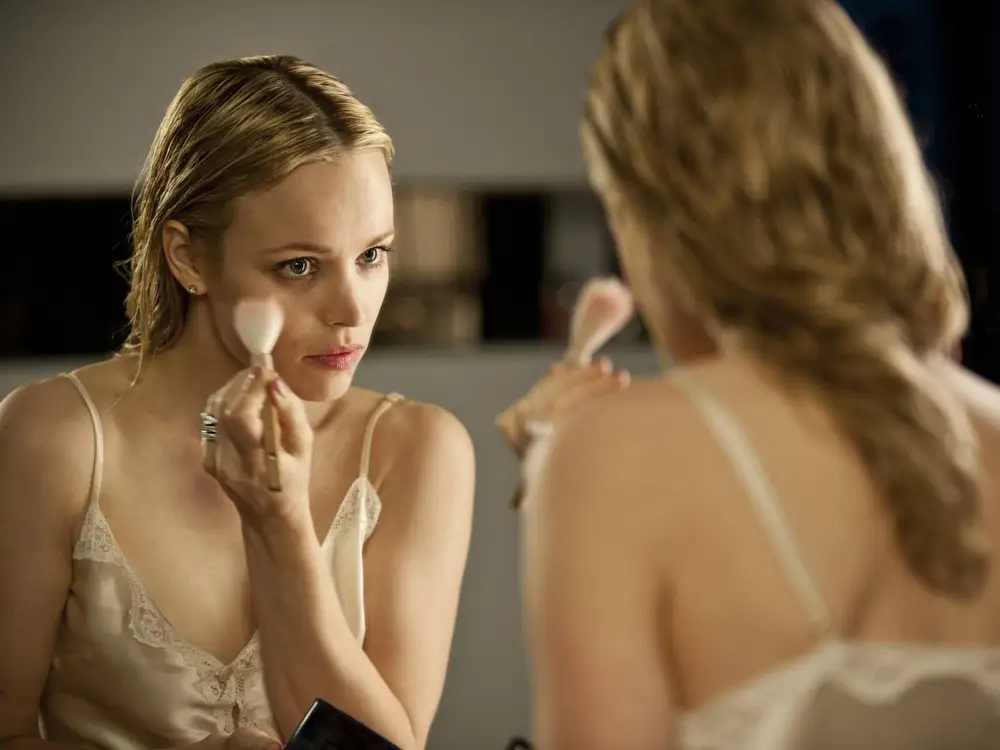What mood does this image evoke, and how is it achieved? The image evokes a mood of tranquility and introspection, achieved through the use of soft lighting, which creates gentle shadows and highlights the calm expression of the woman. Her focused demeanor and the quiet setting, indicated by her attire and the solitary activity of applying makeup, also contribute to the serene atmosphere. 